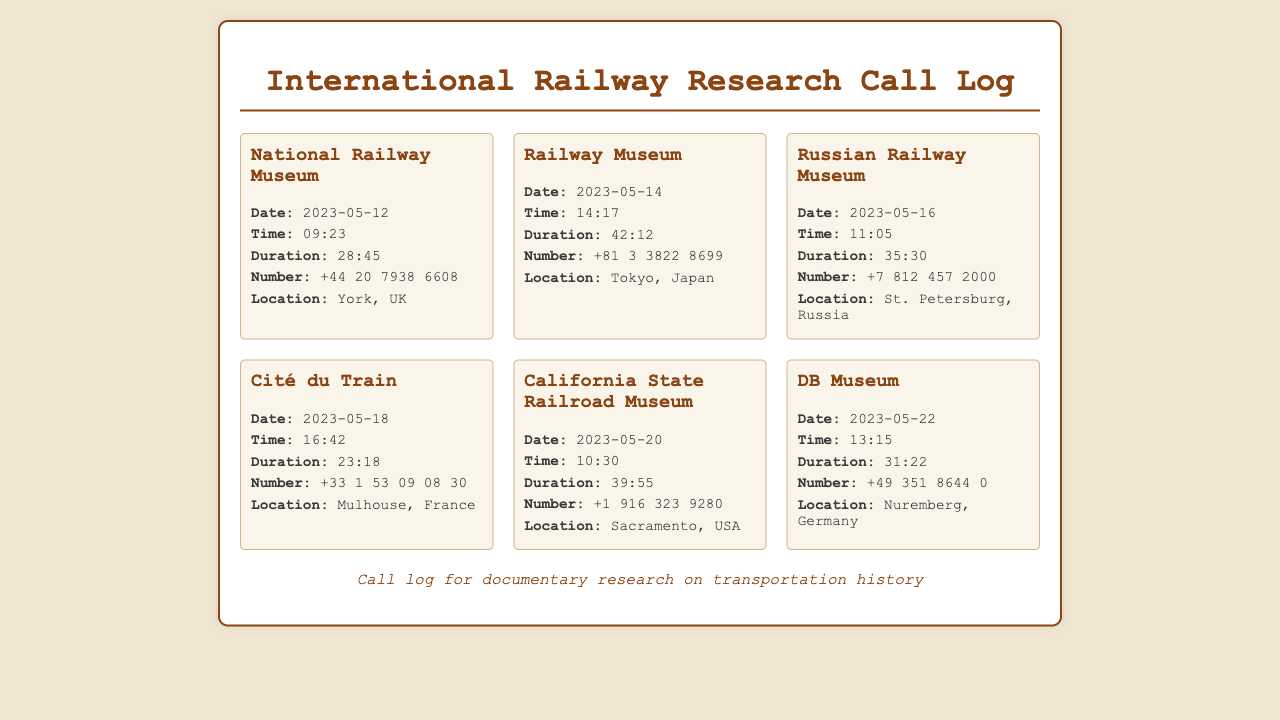What is the date of the call to the National Railway Museum? The date of the call to the National Railway Museum is specifically mentioned in the document as 2023-05-12.
Answer: 2023-05-12 What was the duration of the call to the Railway Museum? The duration of the call to the Railway Museum is detailed in the document, indicating it lasted 42 minutes and 12 seconds.
Answer: 42:12 Which country is the Cité du Train located in? The location of the Cité du Train is explicitly stated as being in Mulhouse, France, thus identifying the country.
Answer: France How many calls were made to museums located in the USA? The document includes specific entries, showing only one call was made to a museum in the USA, which is the California State Railroad Museum.
Answer: 1 What is the phone number for the Russian Railway Museum? The document provides the phone number for the Russian Railway Museum as +7 812 457 2000.
Answer: +7 812 457 2000 Which museum was called on May 18th? Examining the call log, the document reveals that Cité du Train was called on that date.
Answer: Cité du Train What is the longest call duration in the document? Comparing different call durations, the longest duration recorded is for the Railway Museum at 42 minutes and 12 seconds.
Answer: 42:12 Which call occurred first in the log? The document lists calls in chronological order, with the first call to the National Railway Museum on the earliest date.
Answer: National Railway Museum What type of document is this? The nature of the document is specified as a call log for tracking calls related to documentary research.
Answer: Call log 